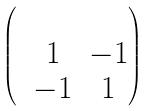<formula> <loc_0><loc_0><loc_500><loc_500>\begin{pmatrix} & & \\ & 1 & - 1 \\ & - 1 & 1 \\ \end{pmatrix}</formula> 